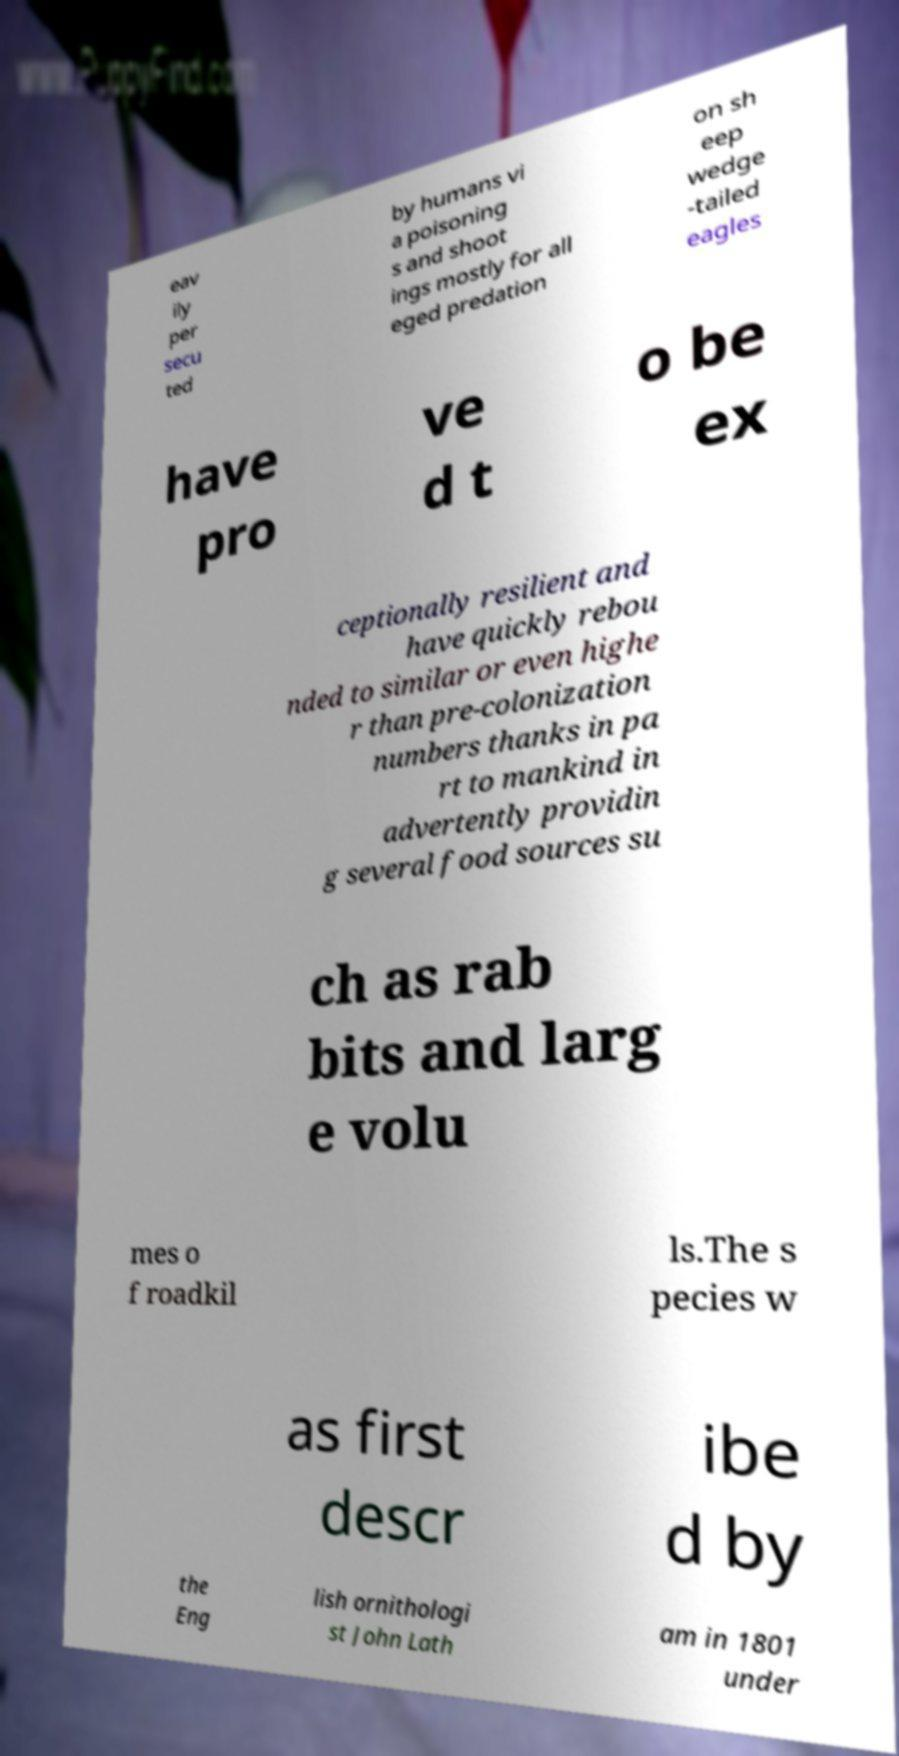What messages or text are displayed in this image? I need them in a readable, typed format. eav ily per secu ted by humans vi a poisoning s and shoot ings mostly for all eged predation on sh eep wedge -tailed eagles have pro ve d t o be ex ceptionally resilient and have quickly rebou nded to similar or even highe r than pre-colonization numbers thanks in pa rt to mankind in advertently providin g several food sources su ch as rab bits and larg e volu mes o f roadkil ls.The s pecies w as first descr ibe d by the Eng lish ornithologi st John Lath am in 1801 under 